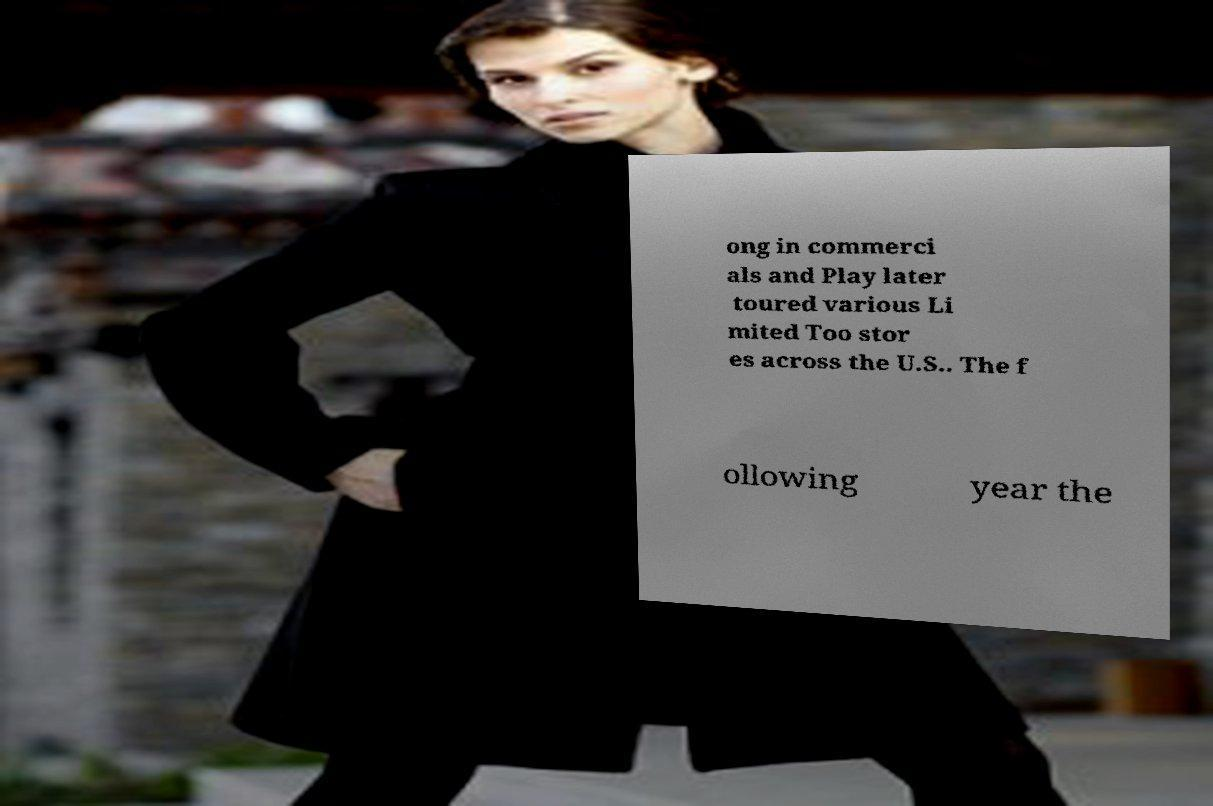Please read and relay the text visible in this image. What does it say? ong in commerci als and Play later toured various Li mited Too stor es across the U.S.. The f ollowing year the 